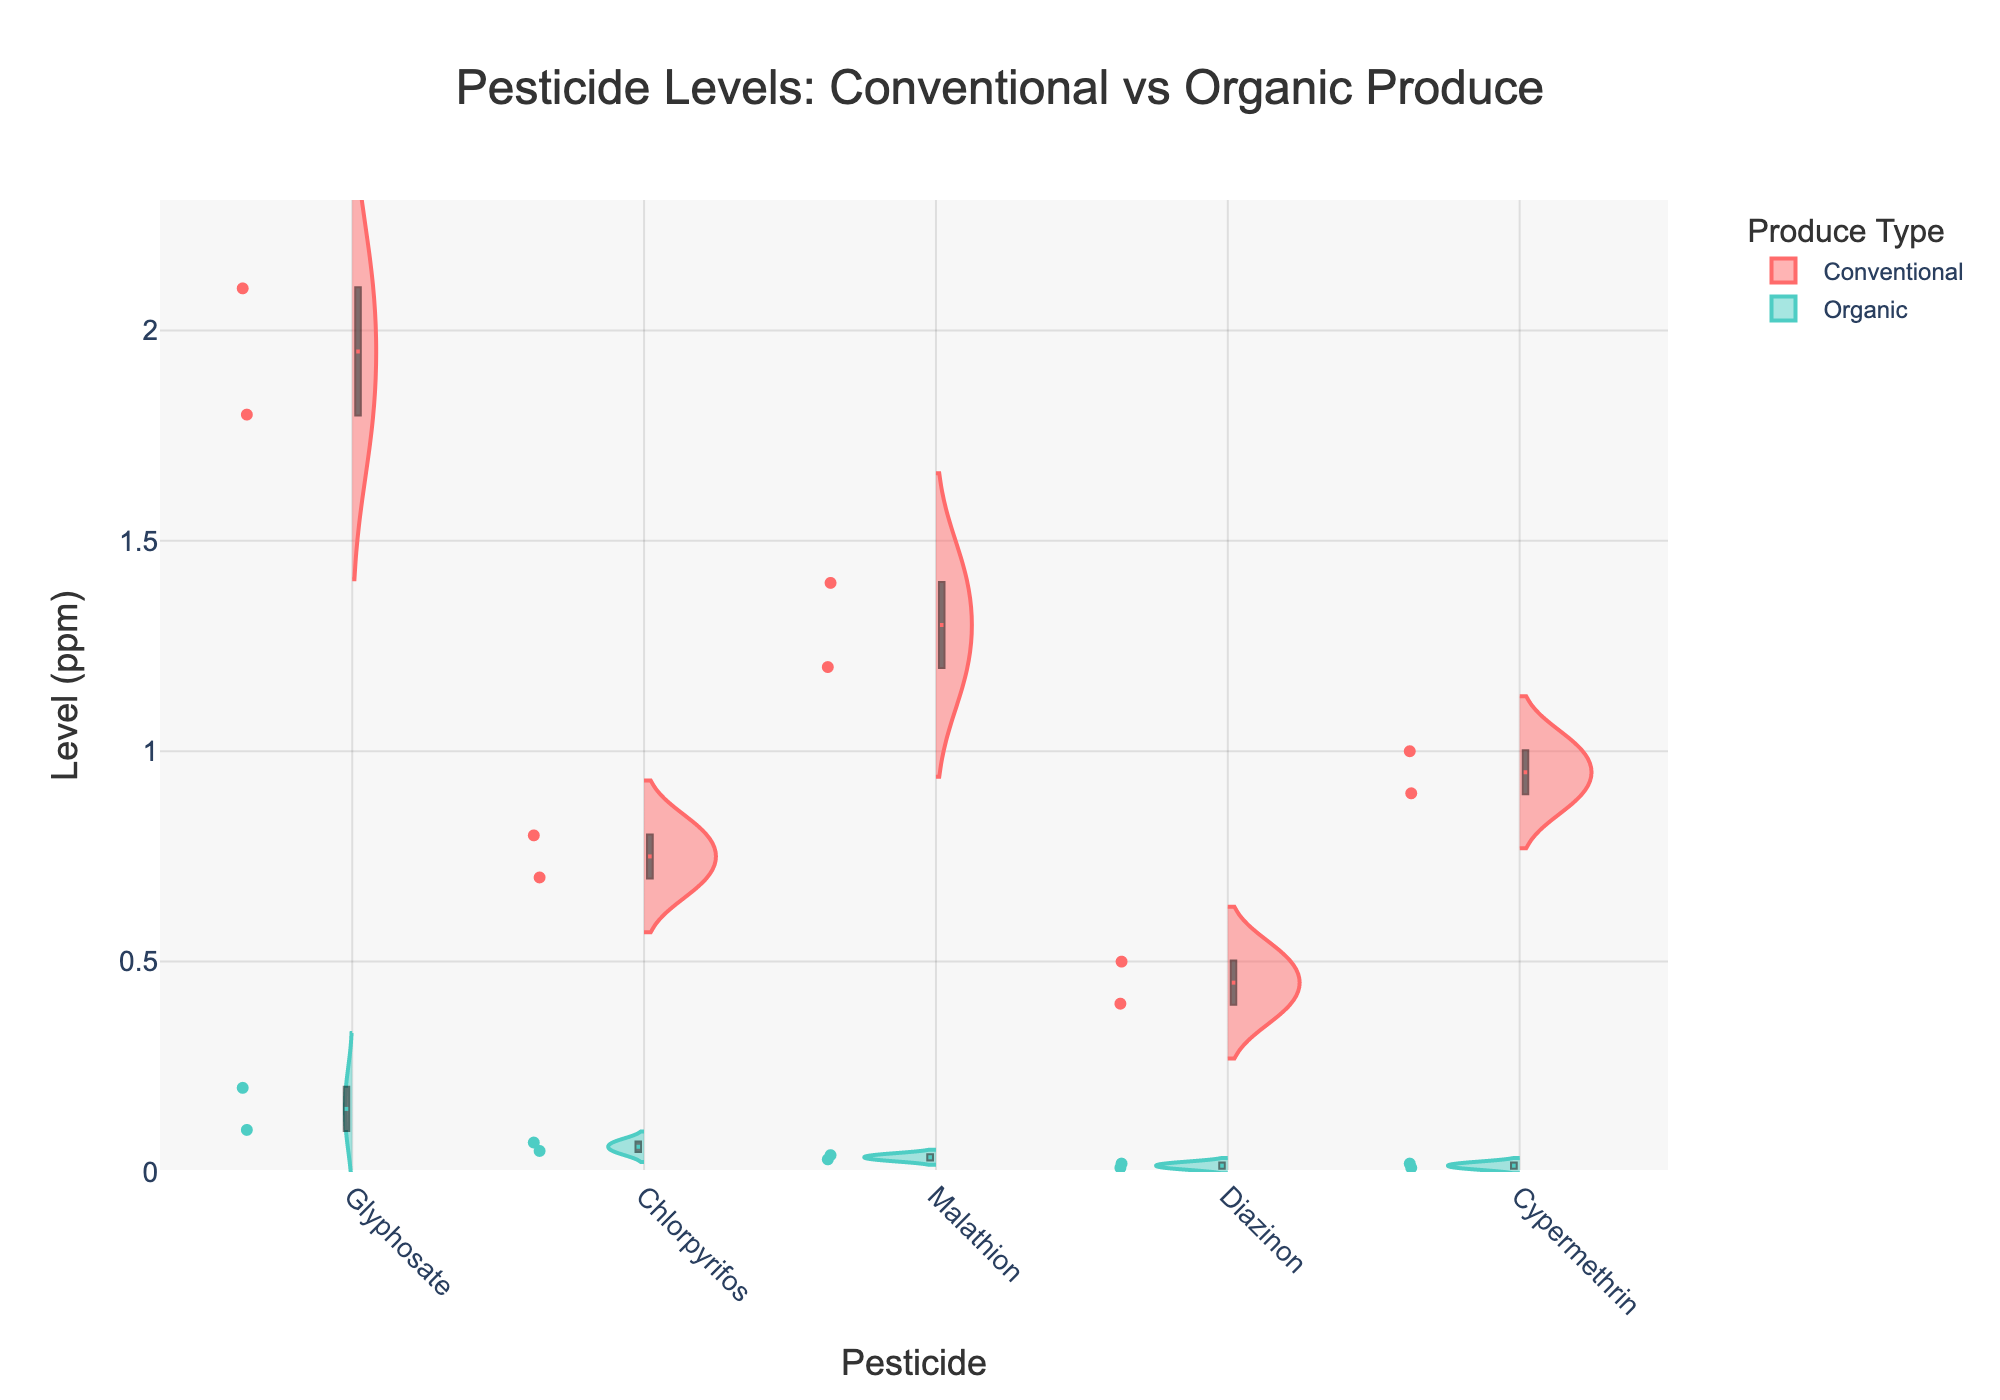What is the maximum pesticide level found in conventional produce? Check the highest point of the violins for conventional produce. The highest level (ppm) for conventional produce is 2.1
Answer: 2.1 ppm Which type shows a wider distribution for Chlorpyrifos levels? Inspect the width of the violins for Chlorpyrifos in both conventional and organic. The conventional produce displays a broader distribution compared to organic.
Answer: Conventional Which pesticide has the lowest median level in organic produce? Look at the median lines in the box plots overlaid on the violins for organic produce. Diazinon has the lowest median level in organic produce, slightly above 0 ppm.
Answer: Diazinon How do the mean levels of Glyphosate compare between conventional and organic produce? Observe the mean lines (dashed) in the violins for Glyphosate in both types. Glyphosate levels in conventional produce are significantly higher than in organic produce.
Answer: Higher in conventional Which pesticide in conventional produce shows the least variation based on the widths of the violins? Evaluate the narrowest span of the violins for pesticides in conventional produce. Diazinon has the least variation, indicated by the narrow violin.
Answer: Diazinon Are there any pesticides found exclusively or almost exclusively in either type of produce? Analyze the violin plots for pesticides in both types of produce. None of the pesticides are exclusively found in one type, but they consistently appear in both.
Answer: No Is the mean level of Malathion higher in conventional or organic produce? Compare the mean lines (dashed) in the violin plots for Malathion in both types. The mean line for conventional produce is higher.
Answer: Conventional Which pesticide has the highest variability in the organic produce? Look at the wide violins for organic produce. Glyphosate shows the highest variability.
Answer: Glyphosate How much higher is the maximum Cypermethrin level in conventional compared to organic produce? Observe the highest points of the Cypermethrin violins for both produce types. The maximum level in conventional is 1 ppm and in organic is 0.02 ppm. The difference is 1 - 0.02 = 0.98 ppm.
Answer: 0.98 ppm What are the central tendencies (medians) for Glyphosate levels in both types of produce? Refer to the box plot lines within the Glyphosate violins for both types. The median for conventional is around 2 ppm, while for organic, it's around 0.15 ppm.
Answer: Conventional: ~2 ppm, Organic: ~0.15 ppm 